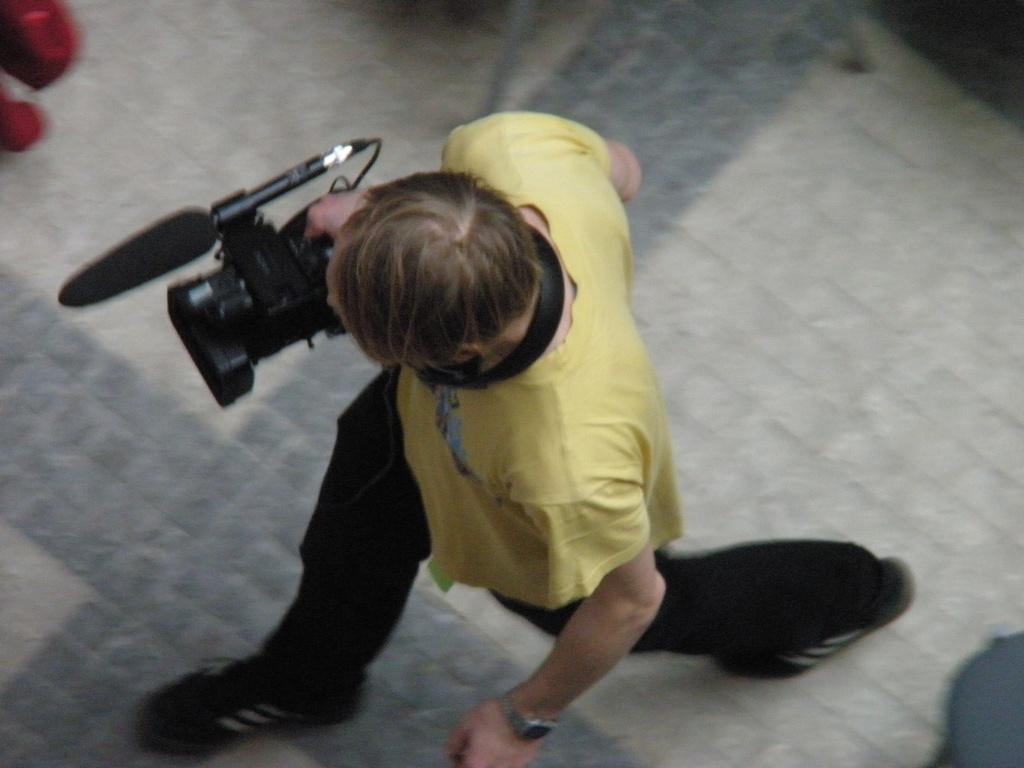Can you describe this image briefly? A person is walking on the floor. This person wore a yellow color t-shirt and also holding a camera. 